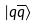<formula> <loc_0><loc_0><loc_500><loc_500>| q \overline { q } \rangle</formula> 